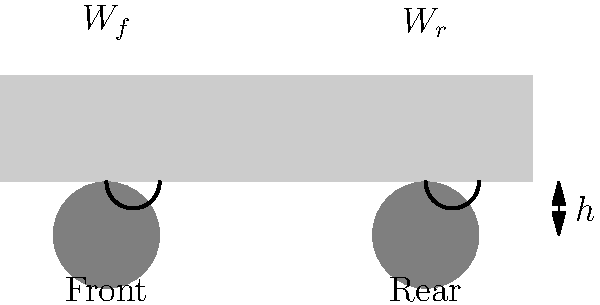You're customizing a client's car, lowering it for a sleek look while maintaining optimal performance. The vehicle weighs 3200 lbs with a 55/45 front-to-rear weight distribution. The client wants a 2-inch drop from the stock ride height. Calculate the ideal spring rate (in lbs/inch) for the front suspension, assuming a motion ratio of 0.6 and aiming for a natural frequency of 1.5 Hz. Let's approach this step-by-step:

1) First, calculate the weight on the front axle:
   $W_f = 0.55 \times 3200 = 1760$ lbs

2) The weight per front wheel:
   $W_{fw} = 1760 \div 2 = 880$ lbs

3) The natural frequency formula is:
   $f_n = \frac{1}{2\pi} \sqrt{\frac{k}{m}}$

   Where:
   $f_n$ is the natural frequency (1.5 Hz)
   $k$ is the spring rate (what we're solving for)
   $m$ is the mass (weight ÷ g, where g = 32.2 ft/s²)

4) Rearrange the formula to solve for $k$:
   $k = (2\pi f_n)^2 \times m$

5) Convert weight to mass:
   $m = \frac{880}{32.2} = 27.33$ slugs

6) Calculate $k$:
   $k = (2\pi \times 1.5)^2 \times 27.33 = 2434$ lbs/ft

7) Convert to lbs/inch:
   $k = 2434 \div 12 = 202.83$ lbs/inch

8) Account for the motion ratio:
   $k_{wheel} = k \div (0.6)^2 = 202.83 \div 0.36 = 563.42$ lbs/inch

Therefore, the ideal spring rate for the front suspension is approximately 563 lbs/inch.
Answer: 563 lbs/inch 